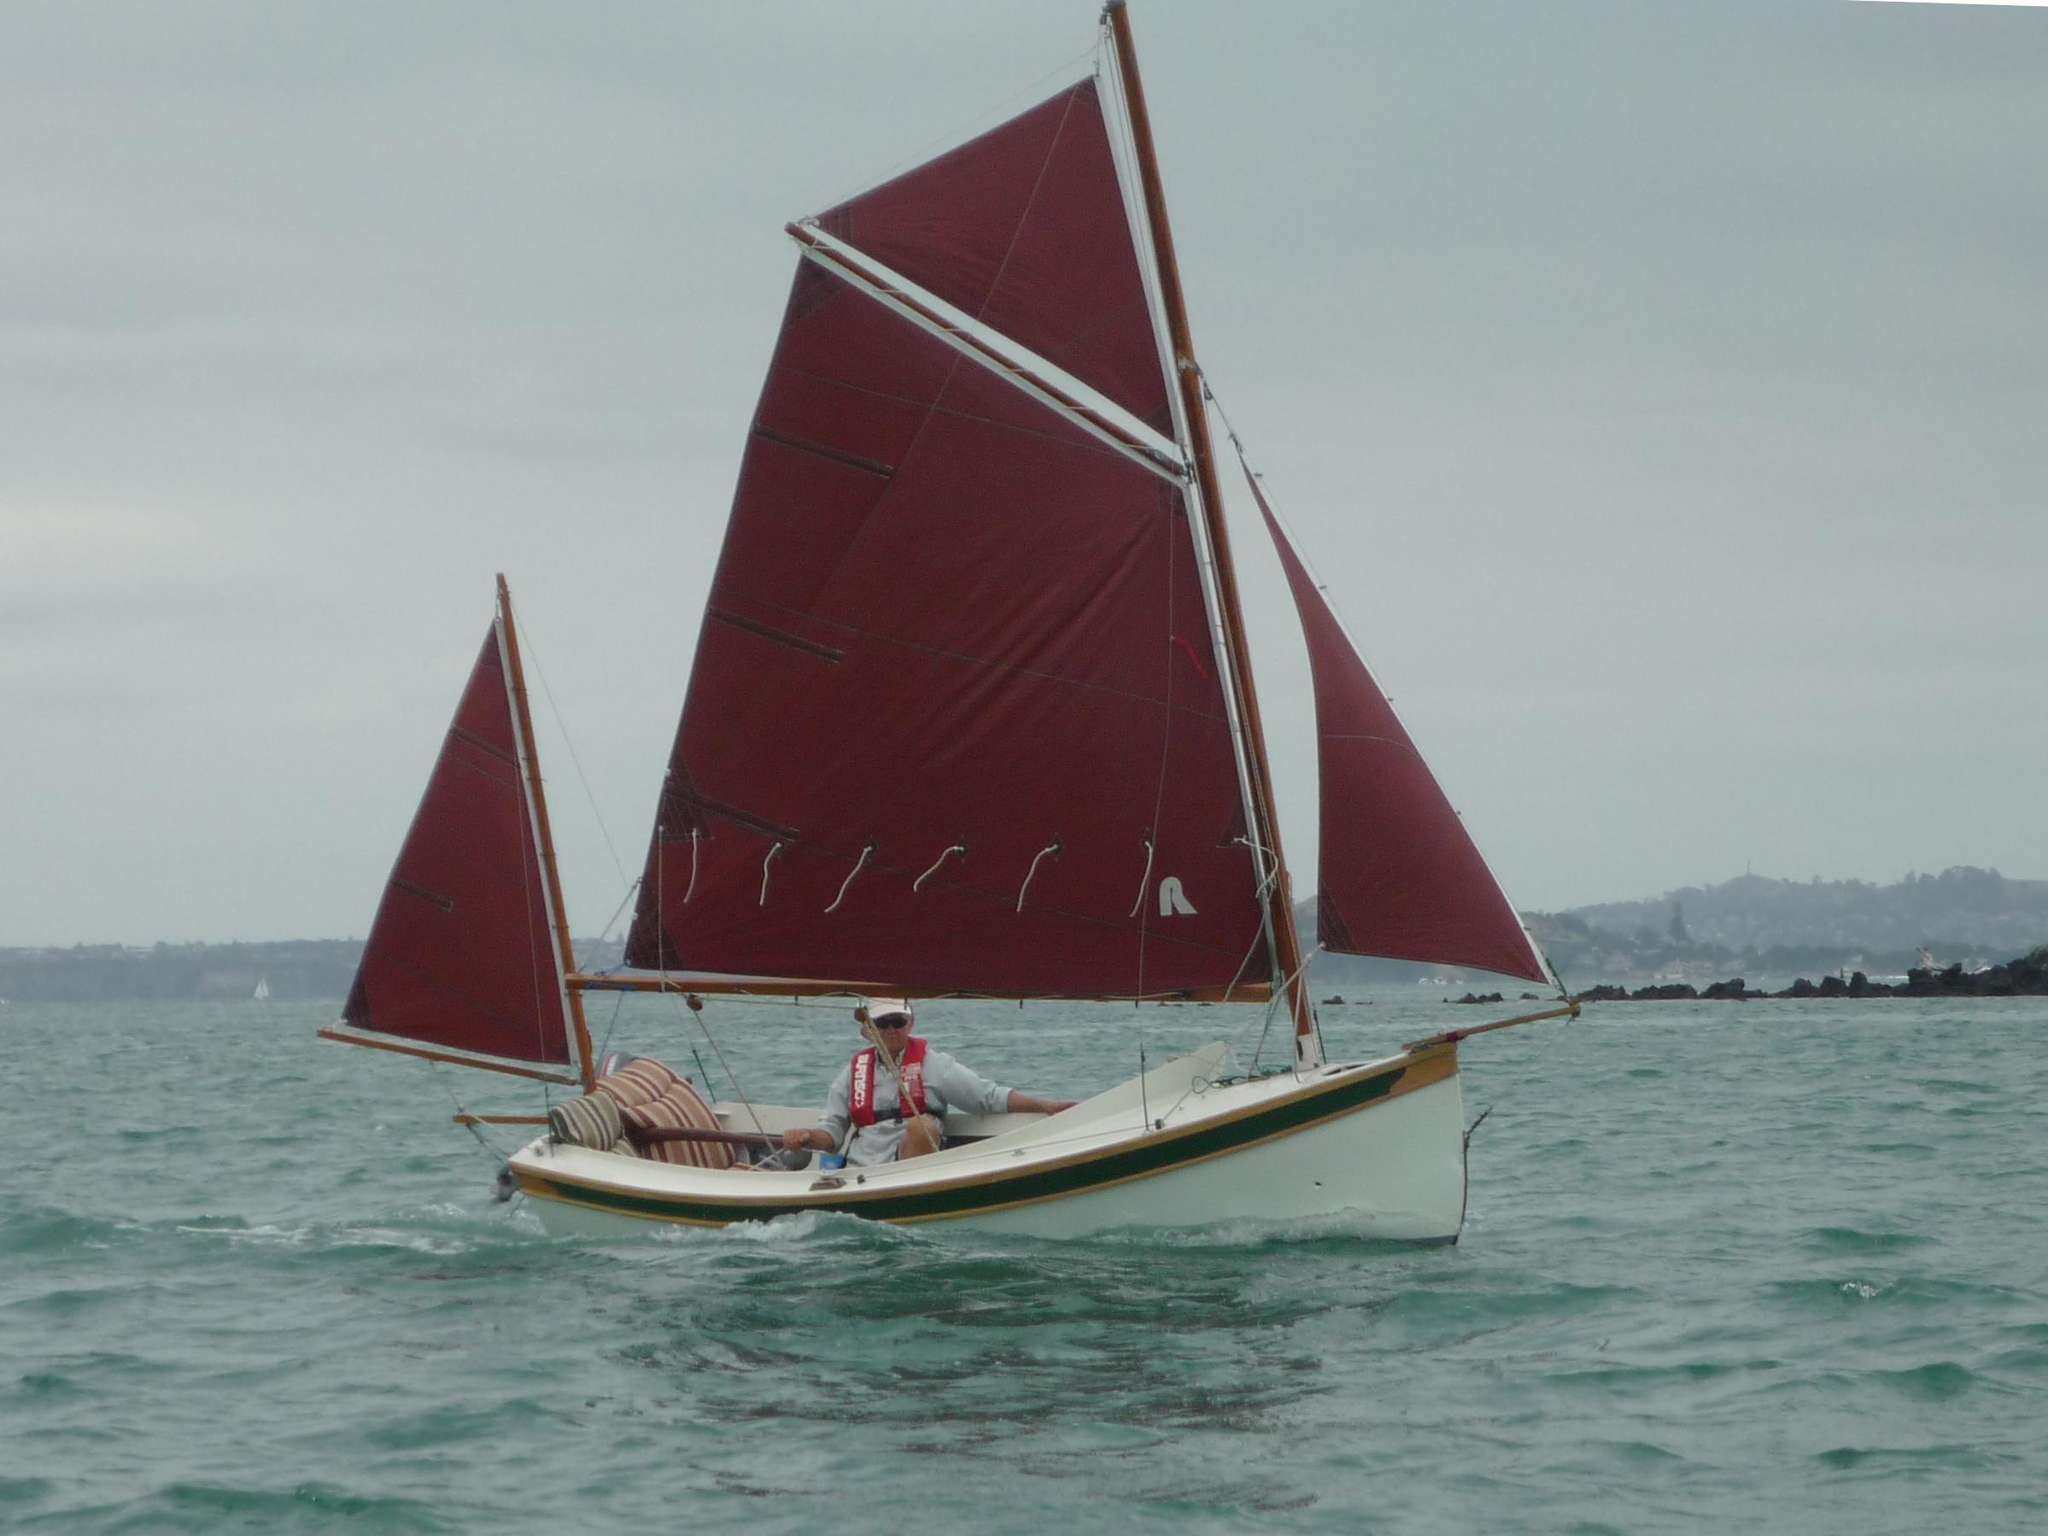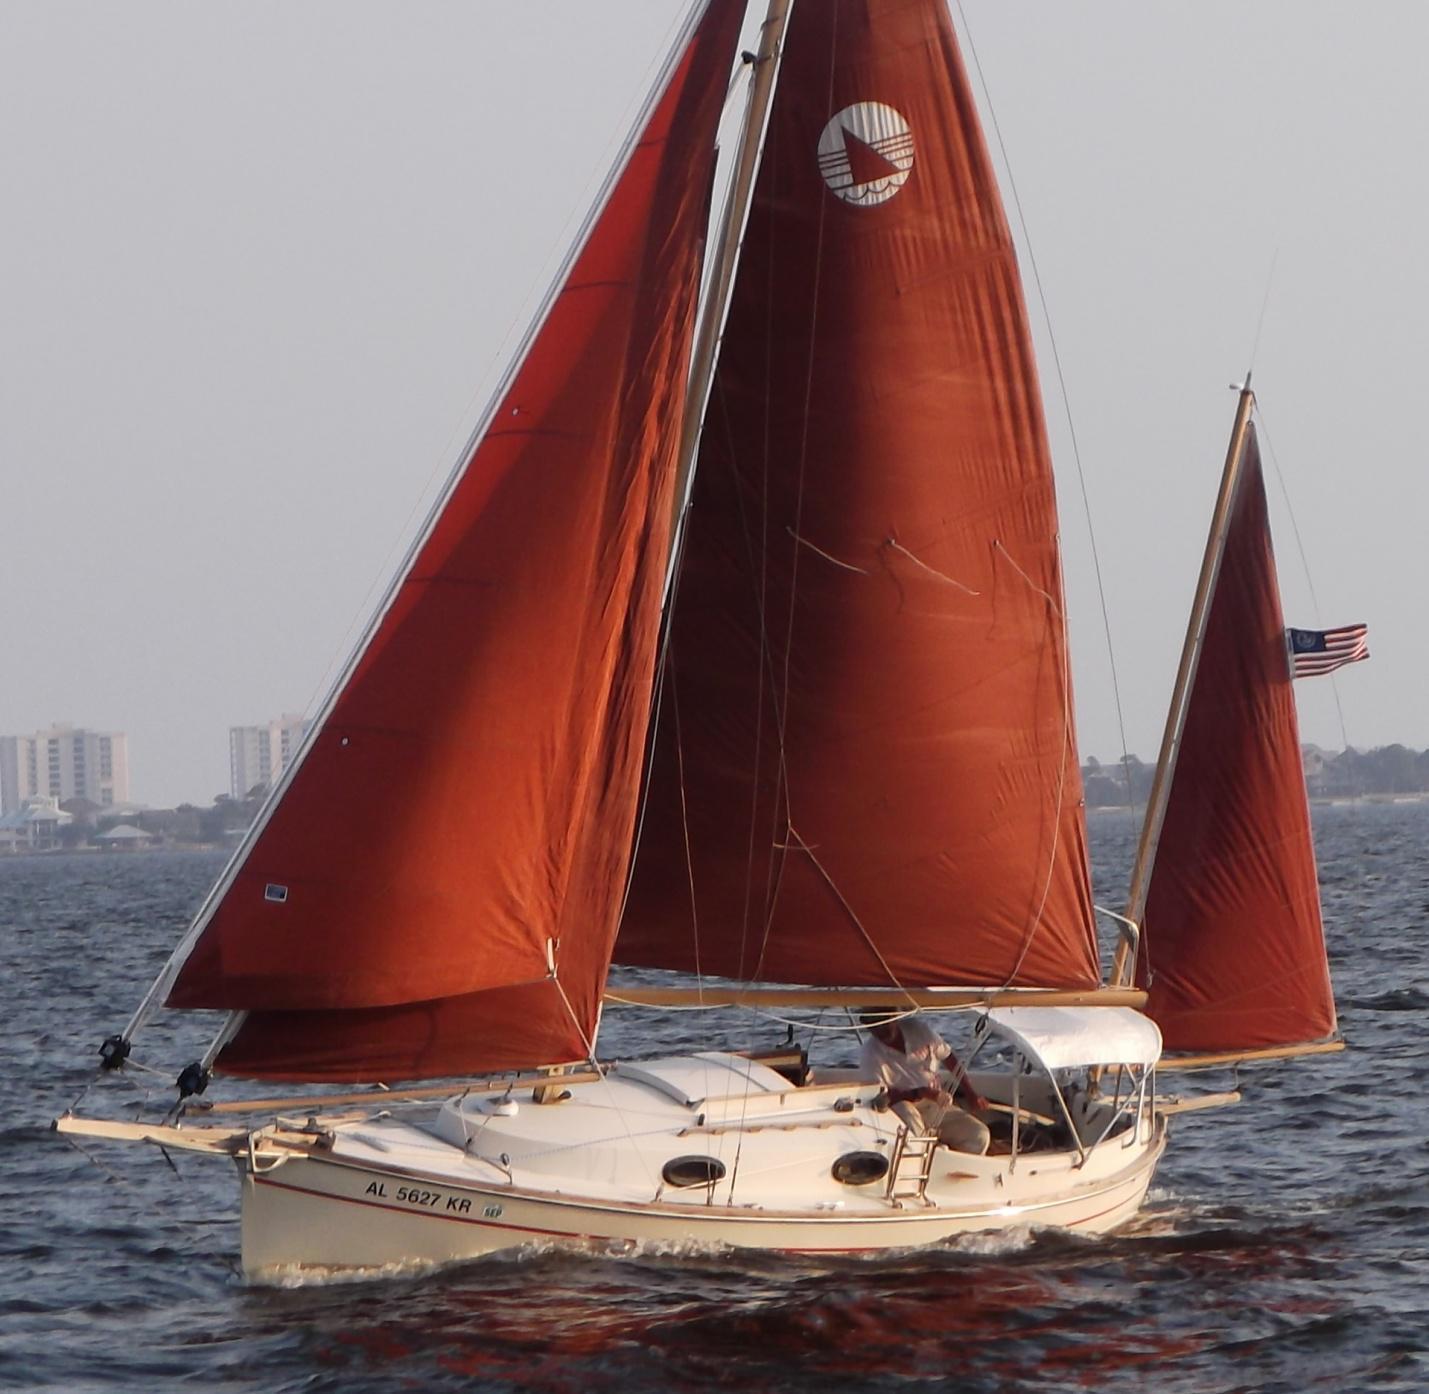The first image is the image on the left, the second image is the image on the right. Evaluate the accuracy of this statement regarding the images: "All boats have sails in the same colour.". Is it true? Answer yes or no. Yes. The first image is the image on the left, the second image is the image on the right. Analyze the images presented: Is the assertion "A total of one sailboat with brown sails is pictured." valid? Answer yes or no. No. 